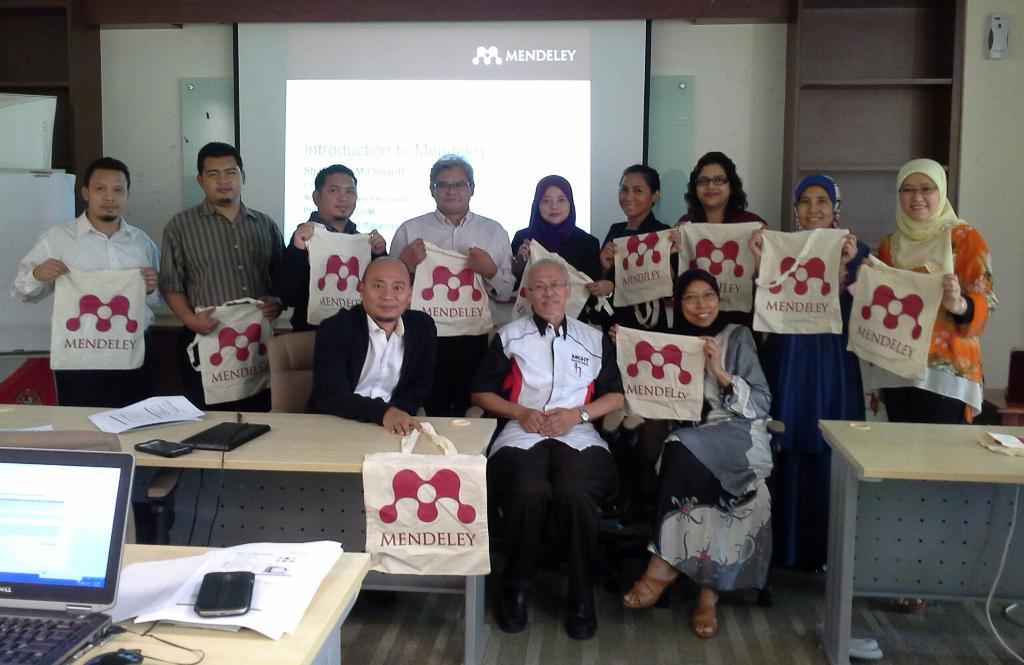How would you summarize this image in a sentence or two? Here we can see that some of them are sitting in front ,and some are standing at back, and holding some bag in their hand, and at back there is the projector, and here is the table and some objects on it, and here is the laptop and papers on it. 